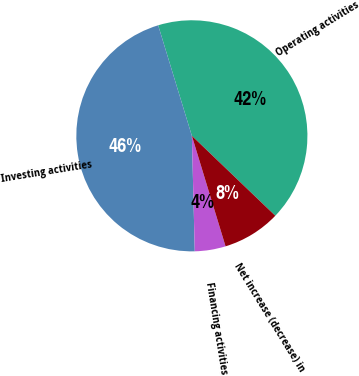<chart> <loc_0><loc_0><loc_500><loc_500><pie_chart><fcel>Operating activities<fcel>Investing activities<fcel>Financing activities<fcel>Net increase (decrease) in<nl><fcel>41.87%<fcel>45.69%<fcel>4.31%<fcel>8.13%<nl></chart> 